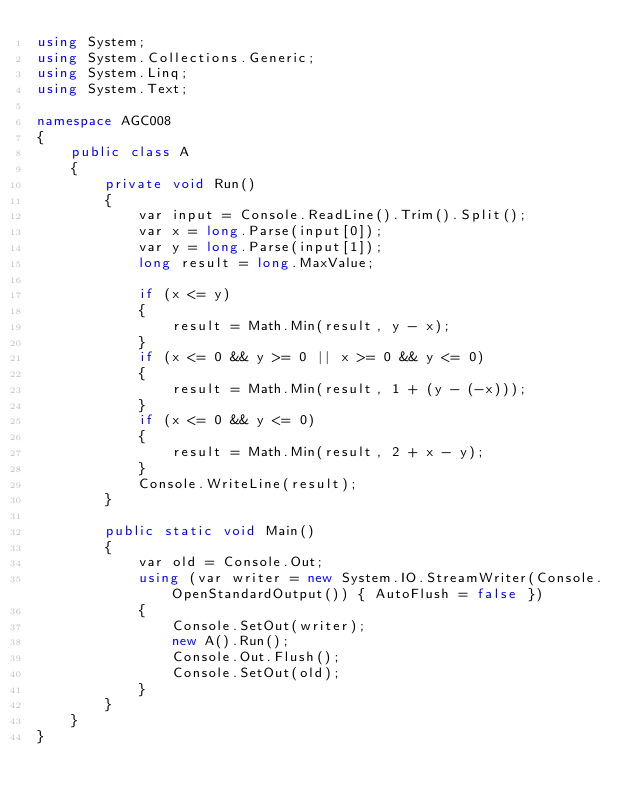Convert code to text. <code><loc_0><loc_0><loc_500><loc_500><_C#_>using System;
using System.Collections.Generic;
using System.Linq;
using System.Text;

namespace AGC008
{
    public class A
    {
        private void Run()
        {
            var input = Console.ReadLine().Trim().Split();
            var x = long.Parse(input[0]);
            var y = long.Parse(input[1]);
            long result = long.MaxValue;

            if (x <= y)
            {
                result = Math.Min(result, y - x);
            }
            if (x <= 0 && y >= 0 || x >= 0 && y <= 0)
            {
                result = Math.Min(result, 1 + (y - (-x)));
            }
            if (x <= 0 && y <= 0)
            {
                result = Math.Min(result, 2 + x - y);
            }
            Console.WriteLine(result);
        }

        public static void Main()
        {
            var old = Console.Out;
            using (var writer = new System.IO.StreamWriter(Console.OpenStandardOutput()) { AutoFlush = false })
            {
                Console.SetOut(writer);
                new A().Run();
                Console.Out.Flush();
                Console.SetOut(old);
            }
        }
    }
}
</code> 